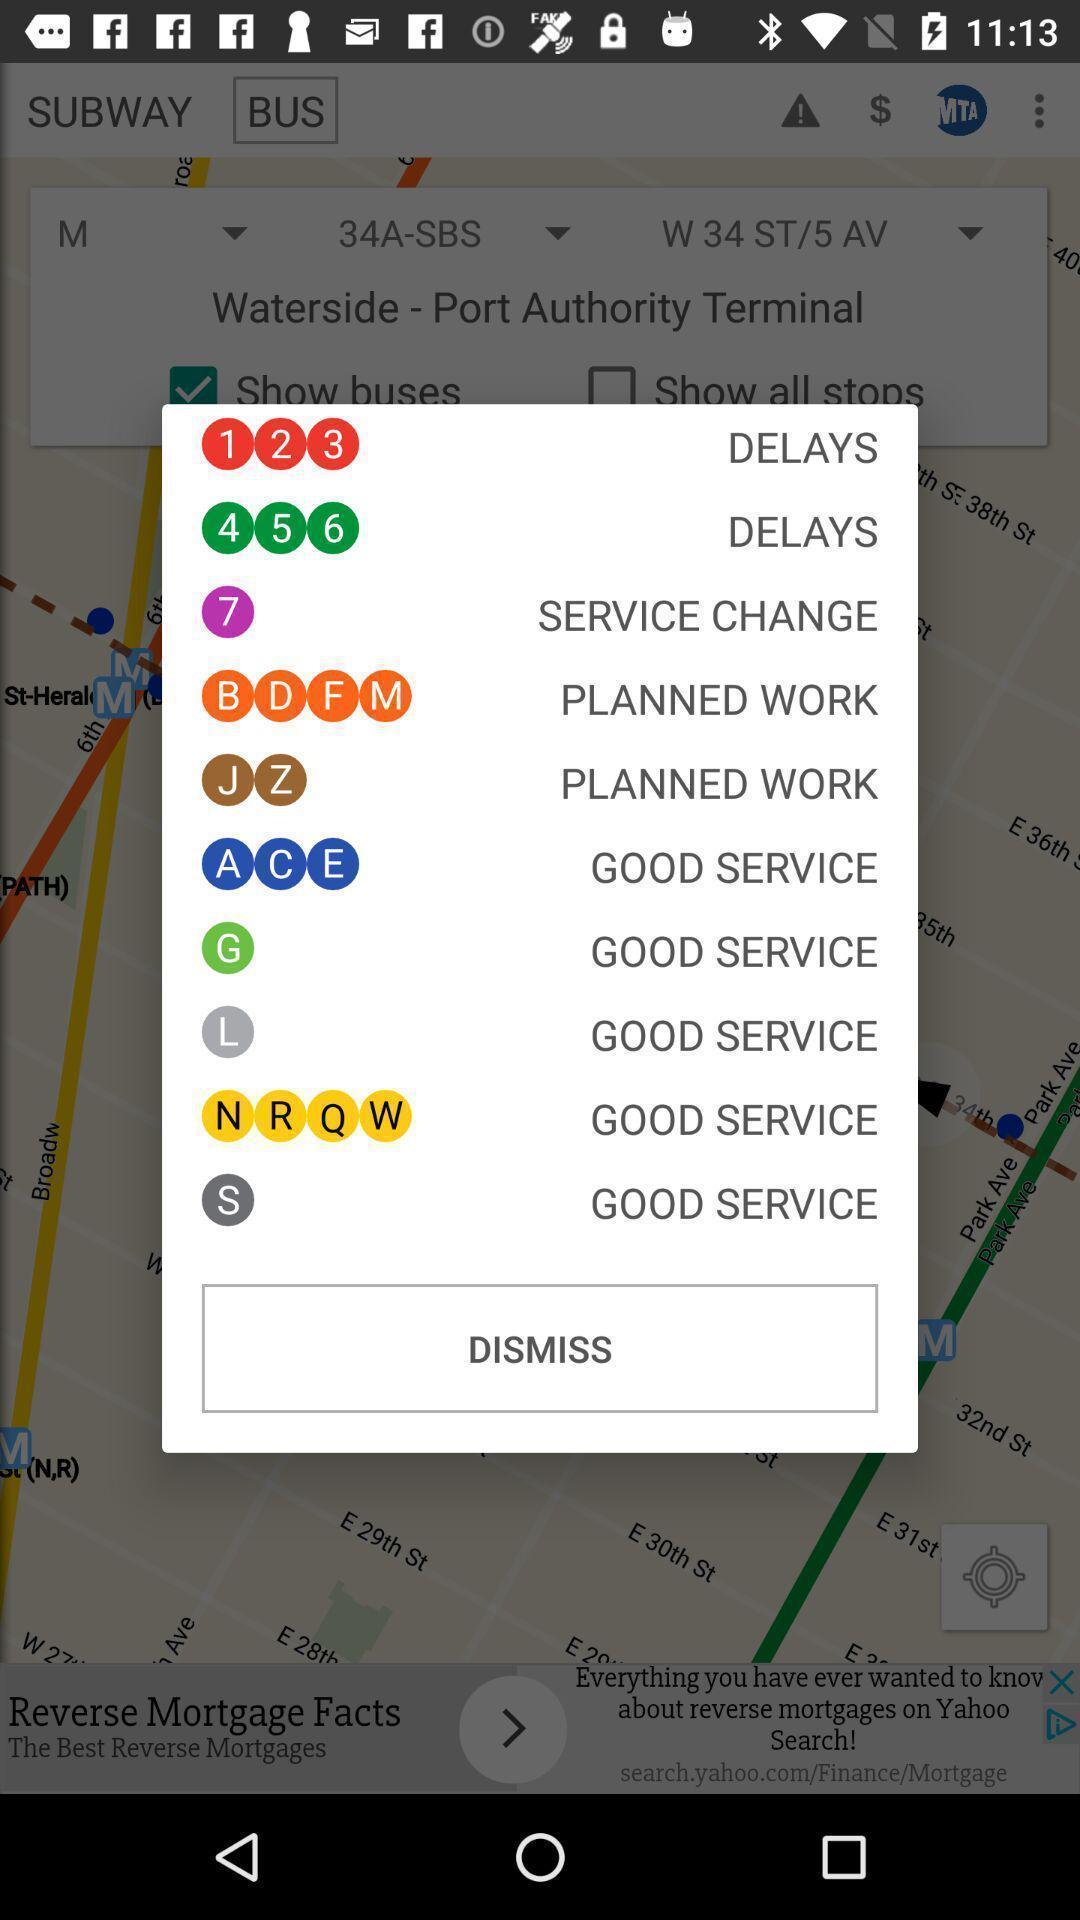Describe the visual elements of this screenshot. Pop-up showing services in the transport app. 